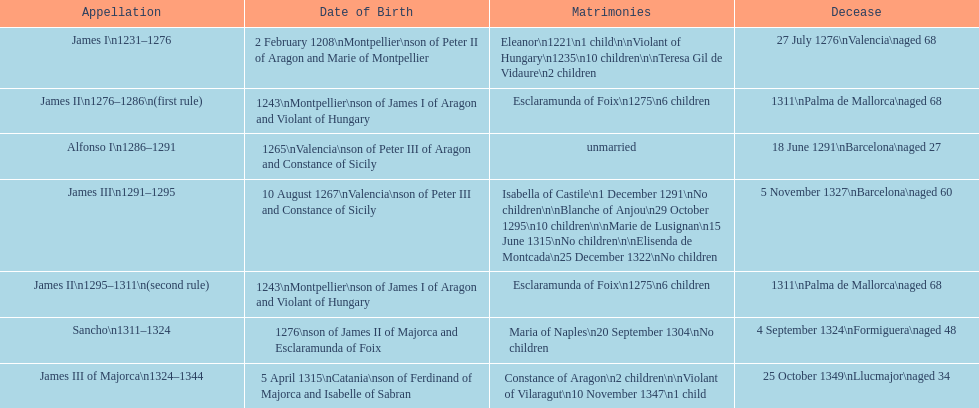What name is above james iii and below james ii? Alfonso I. 